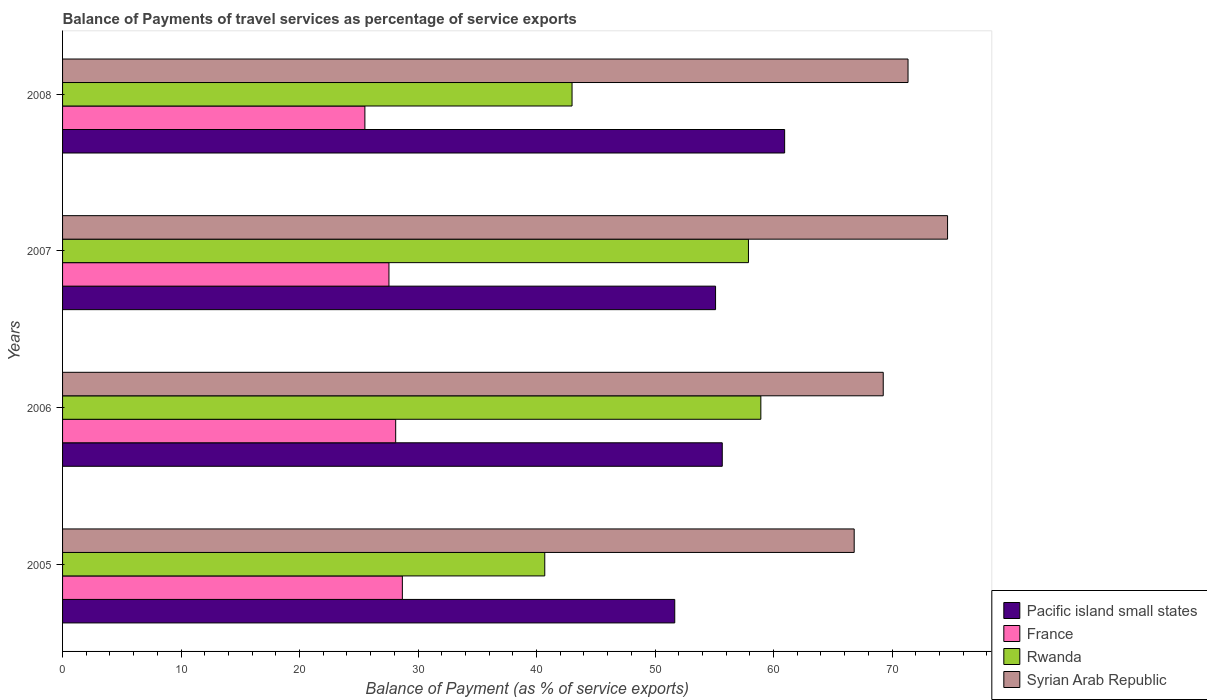How many different coloured bars are there?
Provide a succinct answer. 4. Are the number of bars per tick equal to the number of legend labels?
Your response must be concise. Yes. Are the number of bars on each tick of the Y-axis equal?
Your answer should be compact. Yes. How many bars are there on the 2nd tick from the top?
Make the answer very short. 4. In how many cases, is the number of bars for a given year not equal to the number of legend labels?
Your answer should be very brief. 0. What is the balance of payments of travel services in Syrian Arab Republic in 2006?
Your answer should be very brief. 69.25. Across all years, what is the maximum balance of payments of travel services in Rwanda?
Your answer should be very brief. 58.93. Across all years, what is the minimum balance of payments of travel services in Syrian Arab Republic?
Give a very brief answer. 66.8. What is the total balance of payments of travel services in Rwanda in the graph?
Your answer should be compact. 200.49. What is the difference between the balance of payments of travel services in Syrian Arab Republic in 2007 and that in 2008?
Your answer should be very brief. 3.33. What is the difference between the balance of payments of travel services in Syrian Arab Republic in 2005 and the balance of payments of travel services in France in 2007?
Offer a very short reply. 39.26. What is the average balance of payments of travel services in France per year?
Ensure brevity in your answer.  27.46. In the year 2006, what is the difference between the balance of payments of travel services in Rwanda and balance of payments of travel services in Pacific island small states?
Your response must be concise. 3.25. In how many years, is the balance of payments of travel services in Rwanda greater than 66 %?
Provide a succinct answer. 0. What is the ratio of the balance of payments of travel services in Pacific island small states in 2007 to that in 2008?
Make the answer very short. 0.9. What is the difference between the highest and the second highest balance of payments of travel services in Rwanda?
Offer a very short reply. 1.05. What is the difference between the highest and the lowest balance of payments of travel services in Pacific island small states?
Keep it short and to the point. 9.27. Is the sum of the balance of payments of travel services in France in 2006 and 2008 greater than the maximum balance of payments of travel services in Syrian Arab Republic across all years?
Your answer should be very brief. No. What does the 1st bar from the bottom in 2005 represents?
Your answer should be compact. Pacific island small states. Is it the case that in every year, the sum of the balance of payments of travel services in Rwanda and balance of payments of travel services in Pacific island small states is greater than the balance of payments of travel services in France?
Your response must be concise. Yes. How many bars are there?
Your response must be concise. 16. Are all the bars in the graph horizontal?
Offer a very short reply. Yes. Are the values on the major ticks of X-axis written in scientific E-notation?
Your answer should be compact. No. Does the graph contain any zero values?
Your response must be concise. No. Does the graph contain grids?
Provide a short and direct response. No. Where does the legend appear in the graph?
Your answer should be compact. Bottom right. How many legend labels are there?
Your answer should be very brief. 4. What is the title of the graph?
Make the answer very short. Balance of Payments of travel services as percentage of service exports. Does "Togo" appear as one of the legend labels in the graph?
Your response must be concise. No. What is the label or title of the X-axis?
Your response must be concise. Balance of Payment (as % of service exports). What is the label or title of the Y-axis?
Your response must be concise. Years. What is the Balance of Payment (as % of service exports) in Pacific island small states in 2005?
Your answer should be very brief. 51.66. What is the Balance of Payment (as % of service exports) of France in 2005?
Provide a short and direct response. 28.67. What is the Balance of Payment (as % of service exports) in Rwanda in 2005?
Offer a terse response. 40.69. What is the Balance of Payment (as % of service exports) of Syrian Arab Republic in 2005?
Your answer should be very brief. 66.8. What is the Balance of Payment (as % of service exports) of Pacific island small states in 2006?
Give a very brief answer. 55.67. What is the Balance of Payment (as % of service exports) of France in 2006?
Offer a terse response. 28.11. What is the Balance of Payment (as % of service exports) of Rwanda in 2006?
Ensure brevity in your answer.  58.93. What is the Balance of Payment (as % of service exports) in Syrian Arab Republic in 2006?
Offer a very short reply. 69.25. What is the Balance of Payment (as % of service exports) in Pacific island small states in 2007?
Your response must be concise. 55.1. What is the Balance of Payment (as % of service exports) of France in 2007?
Your response must be concise. 27.54. What is the Balance of Payment (as % of service exports) of Rwanda in 2007?
Make the answer very short. 57.88. What is the Balance of Payment (as % of service exports) of Syrian Arab Republic in 2007?
Offer a terse response. 74.68. What is the Balance of Payment (as % of service exports) in Pacific island small states in 2008?
Your response must be concise. 60.94. What is the Balance of Payment (as % of service exports) in France in 2008?
Keep it short and to the point. 25.51. What is the Balance of Payment (as % of service exports) in Rwanda in 2008?
Offer a terse response. 42.99. What is the Balance of Payment (as % of service exports) of Syrian Arab Republic in 2008?
Your answer should be very brief. 71.35. Across all years, what is the maximum Balance of Payment (as % of service exports) in Pacific island small states?
Provide a short and direct response. 60.94. Across all years, what is the maximum Balance of Payment (as % of service exports) in France?
Your answer should be very brief. 28.67. Across all years, what is the maximum Balance of Payment (as % of service exports) of Rwanda?
Ensure brevity in your answer.  58.93. Across all years, what is the maximum Balance of Payment (as % of service exports) of Syrian Arab Republic?
Your answer should be very brief. 74.68. Across all years, what is the minimum Balance of Payment (as % of service exports) of Pacific island small states?
Give a very brief answer. 51.66. Across all years, what is the minimum Balance of Payment (as % of service exports) of France?
Offer a terse response. 25.51. Across all years, what is the minimum Balance of Payment (as % of service exports) in Rwanda?
Offer a terse response. 40.69. Across all years, what is the minimum Balance of Payment (as % of service exports) in Syrian Arab Republic?
Provide a short and direct response. 66.8. What is the total Balance of Payment (as % of service exports) in Pacific island small states in the graph?
Your answer should be compact. 223.37. What is the total Balance of Payment (as % of service exports) in France in the graph?
Your answer should be very brief. 109.84. What is the total Balance of Payment (as % of service exports) in Rwanda in the graph?
Your response must be concise. 200.49. What is the total Balance of Payment (as % of service exports) in Syrian Arab Republic in the graph?
Offer a very short reply. 282.09. What is the difference between the Balance of Payment (as % of service exports) of Pacific island small states in 2005 and that in 2006?
Provide a short and direct response. -4.01. What is the difference between the Balance of Payment (as % of service exports) of France in 2005 and that in 2006?
Make the answer very short. 0.56. What is the difference between the Balance of Payment (as % of service exports) in Rwanda in 2005 and that in 2006?
Provide a short and direct response. -18.23. What is the difference between the Balance of Payment (as % of service exports) of Syrian Arab Republic in 2005 and that in 2006?
Offer a terse response. -2.45. What is the difference between the Balance of Payment (as % of service exports) in Pacific island small states in 2005 and that in 2007?
Your response must be concise. -3.44. What is the difference between the Balance of Payment (as % of service exports) in France in 2005 and that in 2007?
Provide a short and direct response. 1.13. What is the difference between the Balance of Payment (as % of service exports) of Rwanda in 2005 and that in 2007?
Make the answer very short. -17.19. What is the difference between the Balance of Payment (as % of service exports) in Syrian Arab Republic in 2005 and that in 2007?
Your answer should be compact. -7.88. What is the difference between the Balance of Payment (as % of service exports) in Pacific island small states in 2005 and that in 2008?
Offer a terse response. -9.27. What is the difference between the Balance of Payment (as % of service exports) in France in 2005 and that in 2008?
Ensure brevity in your answer.  3.16. What is the difference between the Balance of Payment (as % of service exports) of Rwanda in 2005 and that in 2008?
Ensure brevity in your answer.  -2.3. What is the difference between the Balance of Payment (as % of service exports) in Syrian Arab Republic in 2005 and that in 2008?
Your response must be concise. -4.54. What is the difference between the Balance of Payment (as % of service exports) of Pacific island small states in 2006 and that in 2007?
Ensure brevity in your answer.  0.57. What is the difference between the Balance of Payment (as % of service exports) of France in 2006 and that in 2007?
Offer a terse response. 0.57. What is the difference between the Balance of Payment (as % of service exports) in Rwanda in 2006 and that in 2007?
Give a very brief answer. 1.05. What is the difference between the Balance of Payment (as % of service exports) in Syrian Arab Republic in 2006 and that in 2007?
Ensure brevity in your answer.  -5.43. What is the difference between the Balance of Payment (as % of service exports) of Pacific island small states in 2006 and that in 2008?
Your response must be concise. -5.26. What is the difference between the Balance of Payment (as % of service exports) of France in 2006 and that in 2008?
Your answer should be compact. 2.6. What is the difference between the Balance of Payment (as % of service exports) in Rwanda in 2006 and that in 2008?
Make the answer very short. 15.93. What is the difference between the Balance of Payment (as % of service exports) of Syrian Arab Republic in 2006 and that in 2008?
Your response must be concise. -2.09. What is the difference between the Balance of Payment (as % of service exports) of Pacific island small states in 2007 and that in 2008?
Your response must be concise. -5.83. What is the difference between the Balance of Payment (as % of service exports) in France in 2007 and that in 2008?
Offer a terse response. 2.03. What is the difference between the Balance of Payment (as % of service exports) of Rwanda in 2007 and that in 2008?
Make the answer very short. 14.89. What is the difference between the Balance of Payment (as % of service exports) in Syrian Arab Republic in 2007 and that in 2008?
Provide a succinct answer. 3.33. What is the difference between the Balance of Payment (as % of service exports) of Pacific island small states in 2005 and the Balance of Payment (as % of service exports) of France in 2006?
Your response must be concise. 23.55. What is the difference between the Balance of Payment (as % of service exports) in Pacific island small states in 2005 and the Balance of Payment (as % of service exports) in Rwanda in 2006?
Keep it short and to the point. -7.27. What is the difference between the Balance of Payment (as % of service exports) in Pacific island small states in 2005 and the Balance of Payment (as % of service exports) in Syrian Arab Republic in 2006?
Give a very brief answer. -17.59. What is the difference between the Balance of Payment (as % of service exports) of France in 2005 and the Balance of Payment (as % of service exports) of Rwanda in 2006?
Make the answer very short. -30.25. What is the difference between the Balance of Payment (as % of service exports) of France in 2005 and the Balance of Payment (as % of service exports) of Syrian Arab Republic in 2006?
Give a very brief answer. -40.58. What is the difference between the Balance of Payment (as % of service exports) in Rwanda in 2005 and the Balance of Payment (as % of service exports) in Syrian Arab Republic in 2006?
Make the answer very short. -28.56. What is the difference between the Balance of Payment (as % of service exports) in Pacific island small states in 2005 and the Balance of Payment (as % of service exports) in France in 2007?
Make the answer very short. 24.12. What is the difference between the Balance of Payment (as % of service exports) in Pacific island small states in 2005 and the Balance of Payment (as % of service exports) in Rwanda in 2007?
Keep it short and to the point. -6.22. What is the difference between the Balance of Payment (as % of service exports) in Pacific island small states in 2005 and the Balance of Payment (as % of service exports) in Syrian Arab Republic in 2007?
Ensure brevity in your answer.  -23.02. What is the difference between the Balance of Payment (as % of service exports) in France in 2005 and the Balance of Payment (as % of service exports) in Rwanda in 2007?
Keep it short and to the point. -29.21. What is the difference between the Balance of Payment (as % of service exports) of France in 2005 and the Balance of Payment (as % of service exports) of Syrian Arab Republic in 2007?
Your answer should be very brief. -46.01. What is the difference between the Balance of Payment (as % of service exports) of Rwanda in 2005 and the Balance of Payment (as % of service exports) of Syrian Arab Republic in 2007?
Keep it short and to the point. -33.99. What is the difference between the Balance of Payment (as % of service exports) of Pacific island small states in 2005 and the Balance of Payment (as % of service exports) of France in 2008?
Ensure brevity in your answer.  26.15. What is the difference between the Balance of Payment (as % of service exports) in Pacific island small states in 2005 and the Balance of Payment (as % of service exports) in Rwanda in 2008?
Your response must be concise. 8.67. What is the difference between the Balance of Payment (as % of service exports) in Pacific island small states in 2005 and the Balance of Payment (as % of service exports) in Syrian Arab Republic in 2008?
Give a very brief answer. -19.69. What is the difference between the Balance of Payment (as % of service exports) in France in 2005 and the Balance of Payment (as % of service exports) in Rwanda in 2008?
Keep it short and to the point. -14.32. What is the difference between the Balance of Payment (as % of service exports) of France in 2005 and the Balance of Payment (as % of service exports) of Syrian Arab Republic in 2008?
Offer a terse response. -42.67. What is the difference between the Balance of Payment (as % of service exports) in Rwanda in 2005 and the Balance of Payment (as % of service exports) in Syrian Arab Republic in 2008?
Keep it short and to the point. -30.66. What is the difference between the Balance of Payment (as % of service exports) of Pacific island small states in 2006 and the Balance of Payment (as % of service exports) of France in 2007?
Your answer should be very brief. 28.13. What is the difference between the Balance of Payment (as % of service exports) in Pacific island small states in 2006 and the Balance of Payment (as % of service exports) in Rwanda in 2007?
Offer a terse response. -2.21. What is the difference between the Balance of Payment (as % of service exports) of Pacific island small states in 2006 and the Balance of Payment (as % of service exports) of Syrian Arab Republic in 2007?
Ensure brevity in your answer.  -19.01. What is the difference between the Balance of Payment (as % of service exports) of France in 2006 and the Balance of Payment (as % of service exports) of Rwanda in 2007?
Provide a short and direct response. -29.77. What is the difference between the Balance of Payment (as % of service exports) in France in 2006 and the Balance of Payment (as % of service exports) in Syrian Arab Republic in 2007?
Keep it short and to the point. -46.57. What is the difference between the Balance of Payment (as % of service exports) in Rwanda in 2006 and the Balance of Payment (as % of service exports) in Syrian Arab Republic in 2007?
Your answer should be compact. -15.76. What is the difference between the Balance of Payment (as % of service exports) of Pacific island small states in 2006 and the Balance of Payment (as % of service exports) of France in 2008?
Your answer should be compact. 30.16. What is the difference between the Balance of Payment (as % of service exports) of Pacific island small states in 2006 and the Balance of Payment (as % of service exports) of Rwanda in 2008?
Your response must be concise. 12.68. What is the difference between the Balance of Payment (as % of service exports) in Pacific island small states in 2006 and the Balance of Payment (as % of service exports) in Syrian Arab Republic in 2008?
Your response must be concise. -15.68. What is the difference between the Balance of Payment (as % of service exports) of France in 2006 and the Balance of Payment (as % of service exports) of Rwanda in 2008?
Offer a very short reply. -14.88. What is the difference between the Balance of Payment (as % of service exports) of France in 2006 and the Balance of Payment (as % of service exports) of Syrian Arab Republic in 2008?
Provide a short and direct response. -43.24. What is the difference between the Balance of Payment (as % of service exports) of Rwanda in 2006 and the Balance of Payment (as % of service exports) of Syrian Arab Republic in 2008?
Make the answer very short. -12.42. What is the difference between the Balance of Payment (as % of service exports) in Pacific island small states in 2007 and the Balance of Payment (as % of service exports) in France in 2008?
Offer a terse response. 29.59. What is the difference between the Balance of Payment (as % of service exports) of Pacific island small states in 2007 and the Balance of Payment (as % of service exports) of Rwanda in 2008?
Provide a succinct answer. 12.11. What is the difference between the Balance of Payment (as % of service exports) in Pacific island small states in 2007 and the Balance of Payment (as % of service exports) in Syrian Arab Republic in 2008?
Offer a terse response. -16.24. What is the difference between the Balance of Payment (as % of service exports) in France in 2007 and the Balance of Payment (as % of service exports) in Rwanda in 2008?
Ensure brevity in your answer.  -15.45. What is the difference between the Balance of Payment (as % of service exports) of France in 2007 and the Balance of Payment (as % of service exports) of Syrian Arab Republic in 2008?
Provide a succinct answer. -43.81. What is the difference between the Balance of Payment (as % of service exports) in Rwanda in 2007 and the Balance of Payment (as % of service exports) in Syrian Arab Republic in 2008?
Your answer should be compact. -13.47. What is the average Balance of Payment (as % of service exports) in Pacific island small states per year?
Keep it short and to the point. 55.84. What is the average Balance of Payment (as % of service exports) in France per year?
Provide a short and direct response. 27.46. What is the average Balance of Payment (as % of service exports) in Rwanda per year?
Offer a terse response. 50.12. What is the average Balance of Payment (as % of service exports) of Syrian Arab Republic per year?
Your answer should be compact. 70.52. In the year 2005, what is the difference between the Balance of Payment (as % of service exports) in Pacific island small states and Balance of Payment (as % of service exports) in France?
Ensure brevity in your answer.  22.99. In the year 2005, what is the difference between the Balance of Payment (as % of service exports) in Pacific island small states and Balance of Payment (as % of service exports) in Rwanda?
Ensure brevity in your answer.  10.97. In the year 2005, what is the difference between the Balance of Payment (as % of service exports) in Pacific island small states and Balance of Payment (as % of service exports) in Syrian Arab Republic?
Provide a short and direct response. -15.14. In the year 2005, what is the difference between the Balance of Payment (as % of service exports) of France and Balance of Payment (as % of service exports) of Rwanda?
Offer a very short reply. -12.02. In the year 2005, what is the difference between the Balance of Payment (as % of service exports) in France and Balance of Payment (as % of service exports) in Syrian Arab Republic?
Your answer should be very brief. -38.13. In the year 2005, what is the difference between the Balance of Payment (as % of service exports) of Rwanda and Balance of Payment (as % of service exports) of Syrian Arab Republic?
Give a very brief answer. -26.11. In the year 2006, what is the difference between the Balance of Payment (as % of service exports) in Pacific island small states and Balance of Payment (as % of service exports) in France?
Keep it short and to the point. 27.56. In the year 2006, what is the difference between the Balance of Payment (as % of service exports) of Pacific island small states and Balance of Payment (as % of service exports) of Rwanda?
Ensure brevity in your answer.  -3.25. In the year 2006, what is the difference between the Balance of Payment (as % of service exports) of Pacific island small states and Balance of Payment (as % of service exports) of Syrian Arab Republic?
Make the answer very short. -13.58. In the year 2006, what is the difference between the Balance of Payment (as % of service exports) of France and Balance of Payment (as % of service exports) of Rwanda?
Your answer should be very brief. -30.82. In the year 2006, what is the difference between the Balance of Payment (as % of service exports) of France and Balance of Payment (as % of service exports) of Syrian Arab Republic?
Your response must be concise. -41.14. In the year 2006, what is the difference between the Balance of Payment (as % of service exports) in Rwanda and Balance of Payment (as % of service exports) in Syrian Arab Republic?
Your answer should be compact. -10.33. In the year 2007, what is the difference between the Balance of Payment (as % of service exports) of Pacific island small states and Balance of Payment (as % of service exports) of France?
Keep it short and to the point. 27.56. In the year 2007, what is the difference between the Balance of Payment (as % of service exports) in Pacific island small states and Balance of Payment (as % of service exports) in Rwanda?
Your answer should be compact. -2.78. In the year 2007, what is the difference between the Balance of Payment (as % of service exports) of Pacific island small states and Balance of Payment (as % of service exports) of Syrian Arab Republic?
Provide a short and direct response. -19.58. In the year 2007, what is the difference between the Balance of Payment (as % of service exports) in France and Balance of Payment (as % of service exports) in Rwanda?
Keep it short and to the point. -30.34. In the year 2007, what is the difference between the Balance of Payment (as % of service exports) of France and Balance of Payment (as % of service exports) of Syrian Arab Republic?
Your answer should be very brief. -47.14. In the year 2007, what is the difference between the Balance of Payment (as % of service exports) in Rwanda and Balance of Payment (as % of service exports) in Syrian Arab Republic?
Provide a succinct answer. -16.8. In the year 2008, what is the difference between the Balance of Payment (as % of service exports) of Pacific island small states and Balance of Payment (as % of service exports) of France?
Offer a very short reply. 35.42. In the year 2008, what is the difference between the Balance of Payment (as % of service exports) in Pacific island small states and Balance of Payment (as % of service exports) in Rwanda?
Offer a terse response. 17.94. In the year 2008, what is the difference between the Balance of Payment (as % of service exports) of Pacific island small states and Balance of Payment (as % of service exports) of Syrian Arab Republic?
Offer a terse response. -10.41. In the year 2008, what is the difference between the Balance of Payment (as % of service exports) in France and Balance of Payment (as % of service exports) in Rwanda?
Provide a short and direct response. -17.48. In the year 2008, what is the difference between the Balance of Payment (as % of service exports) in France and Balance of Payment (as % of service exports) in Syrian Arab Republic?
Give a very brief answer. -45.84. In the year 2008, what is the difference between the Balance of Payment (as % of service exports) in Rwanda and Balance of Payment (as % of service exports) in Syrian Arab Republic?
Your response must be concise. -28.35. What is the ratio of the Balance of Payment (as % of service exports) of Pacific island small states in 2005 to that in 2006?
Your answer should be compact. 0.93. What is the ratio of the Balance of Payment (as % of service exports) of France in 2005 to that in 2006?
Provide a short and direct response. 1.02. What is the ratio of the Balance of Payment (as % of service exports) of Rwanda in 2005 to that in 2006?
Your answer should be very brief. 0.69. What is the ratio of the Balance of Payment (as % of service exports) in Syrian Arab Republic in 2005 to that in 2006?
Your answer should be compact. 0.96. What is the ratio of the Balance of Payment (as % of service exports) of Pacific island small states in 2005 to that in 2007?
Provide a succinct answer. 0.94. What is the ratio of the Balance of Payment (as % of service exports) in France in 2005 to that in 2007?
Your response must be concise. 1.04. What is the ratio of the Balance of Payment (as % of service exports) of Rwanda in 2005 to that in 2007?
Offer a very short reply. 0.7. What is the ratio of the Balance of Payment (as % of service exports) in Syrian Arab Republic in 2005 to that in 2007?
Offer a terse response. 0.89. What is the ratio of the Balance of Payment (as % of service exports) of Pacific island small states in 2005 to that in 2008?
Your response must be concise. 0.85. What is the ratio of the Balance of Payment (as % of service exports) in France in 2005 to that in 2008?
Your answer should be compact. 1.12. What is the ratio of the Balance of Payment (as % of service exports) in Rwanda in 2005 to that in 2008?
Offer a terse response. 0.95. What is the ratio of the Balance of Payment (as % of service exports) in Syrian Arab Republic in 2005 to that in 2008?
Make the answer very short. 0.94. What is the ratio of the Balance of Payment (as % of service exports) in Pacific island small states in 2006 to that in 2007?
Your answer should be compact. 1.01. What is the ratio of the Balance of Payment (as % of service exports) of France in 2006 to that in 2007?
Offer a terse response. 1.02. What is the ratio of the Balance of Payment (as % of service exports) in Rwanda in 2006 to that in 2007?
Make the answer very short. 1.02. What is the ratio of the Balance of Payment (as % of service exports) of Syrian Arab Republic in 2006 to that in 2007?
Give a very brief answer. 0.93. What is the ratio of the Balance of Payment (as % of service exports) in Pacific island small states in 2006 to that in 2008?
Provide a succinct answer. 0.91. What is the ratio of the Balance of Payment (as % of service exports) in France in 2006 to that in 2008?
Your answer should be very brief. 1.1. What is the ratio of the Balance of Payment (as % of service exports) of Rwanda in 2006 to that in 2008?
Your answer should be very brief. 1.37. What is the ratio of the Balance of Payment (as % of service exports) in Syrian Arab Republic in 2006 to that in 2008?
Your answer should be compact. 0.97. What is the ratio of the Balance of Payment (as % of service exports) of Pacific island small states in 2007 to that in 2008?
Keep it short and to the point. 0.9. What is the ratio of the Balance of Payment (as % of service exports) of France in 2007 to that in 2008?
Keep it short and to the point. 1.08. What is the ratio of the Balance of Payment (as % of service exports) of Rwanda in 2007 to that in 2008?
Your answer should be very brief. 1.35. What is the ratio of the Balance of Payment (as % of service exports) of Syrian Arab Republic in 2007 to that in 2008?
Offer a terse response. 1.05. What is the difference between the highest and the second highest Balance of Payment (as % of service exports) in Pacific island small states?
Make the answer very short. 5.26. What is the difference between the highest and the second highest Balance of Payment (as % of service exports) in France?
Keep it short and to the point. 0.56. What is the difference between the highest and the second highest Balance of Payment (as % of service exports) of Rwanda?
Make the answer very short. 1.05. What is the difference between the highest and the second highest Balance of Payment (as % of service exports) in Syrian Arab Republic?
Keep it short and to the point. 3.33. What is the difference between the highest and the lowest Balance of Payment (as % of service exports) in Pacific island small states?
Your answer should be compact. 9.27. What is the difference between the highest and the lowest Balance of Payment (as % of service exports) in France?
Your answer should be compact. 3.16. What is the difference between the highest and the lowest Balance of Payment (as % of service exports) in Rwanda?
Offer a terse response. 18.23. What is the difference between the highest and the lowest Balance of Payment (as % of service exports) in Syrian Arab Republic?
Keep it short and to the point. 7.88. 